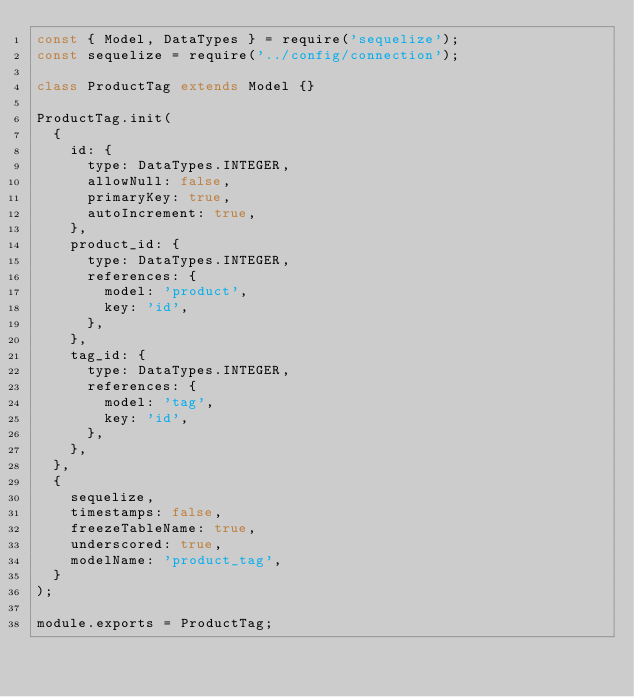<code> <loc_0><loc_0><loc_500><loc_500><_JavaScript_>const { Model, DataTypes } = require('sequelize');
const sequelize = require('../config/connection');

class ProductTag extends Model {}

ProductTag.init(
  {
    id: {
      type: DataTypes.INTEGER,
      allowNull: false,
      primaryKey: true,
      autoIncrement: true,
    },
    product_id: {
      type: DataTypes.INTEGER,
      references: {
        model: 'product',
        key: 'id',
      },
    },
    tag_id: {
      type: DataTypes.INTEGER,
      references: {
        model: 'tag',
        key: 'id',
      },
    },
  },
  {
    sequelize,
    timestamps: false,
    freezeTableName: true,
    underscored: true,
    modelName: 'product_tag',
  }
);

module.exports = ProductTag;</code> 